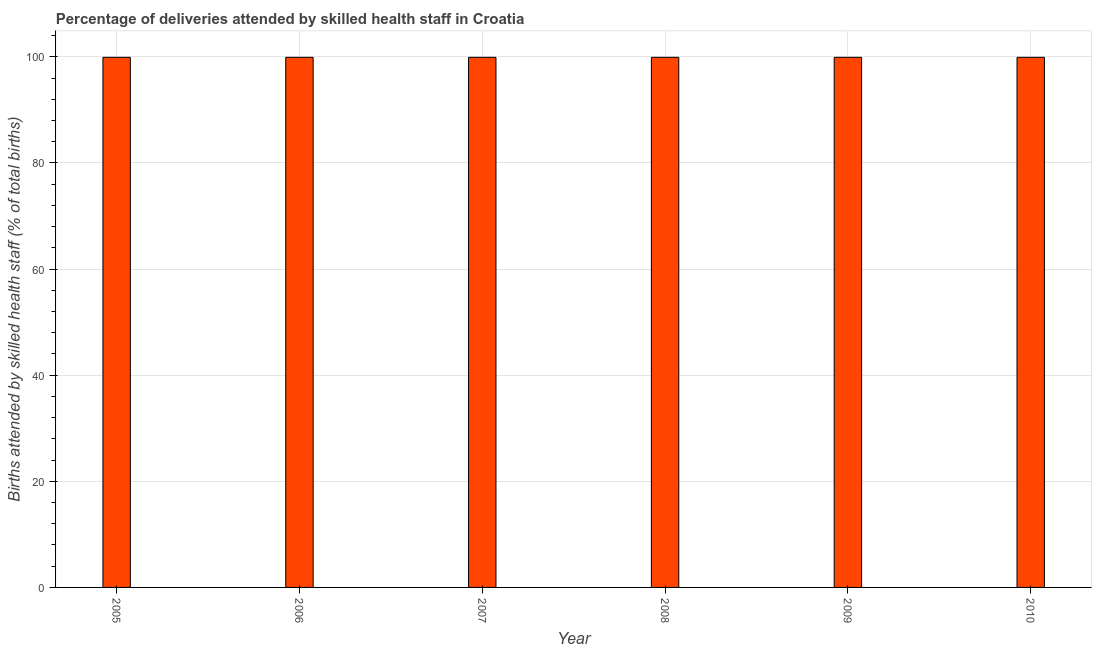What is the title of the graph?
Your answer should be compact. Percentage of deliveries attended by skilled health staff in Croatia. What is the label or title of the Y-axis?
Your response must be concise. Births attended by skilled health staff (% of total births). What is the number of births attended by skilled health staff in 2009?
Keep it short and to the point. 99.9. Across all years, what is the maximum number of births attended by skilled health staff?
Your answer should be very brief. 99.9. Across all years, what is the minimum number of births attended by skilled health staff?
Make the answer very short. 99.9. In which year was the number of births attended by skilled health staff minimum?
Your answer should be compact. 2005. What is the sum of the number of births attended by skilled health staff?
Provide a succinct answer. 599.4. What is the average number of births attended by skilled health staff per year?
Make the answer very short. 99.9. What is the median number of births attended by skilled health staff?
Give a very brief answer. 99.9. Do a majority of the years between 2008 and 2006 (inclusive) have number of births attended by skilled health staff greater than 40 %?
Provide a short and direct response. Yes. Is the number of births attended by skilled health staff in 2007 less than that in 2008?
Your answer should be very brief. No. Is the difference between the number of births attended by skilled health staff in 2005 and 2010 greater than the difference between any two years?
Your response must be concise. Yes. Is the sum of the number of births attended by skilled health staff in 2006 and 2007 greater than the maximum number of births attended by skilled health staff across all years?
Provide a short and direct response. Yes. What is the difference between the highest and the lowest number of births attended by skilled health staff?
Offer a very short reply. 0. In how many years, is the number of births attended by skilled health staff greater than the average number of births attended by skilled health staff taken over all years?
Provide a succinct answer. 6. How many bars are there?
Your answer should be very brief. 6. Are all the bars in the graph horizontal?
Keep it short and to the point. No. How many years are there in the graph?
Make the answer very short. 6. What is the difference between two consecutive major ticks on the Y-axis?
Your response must be concise. 20. Are the values on the major ticks of Y-axis written in scientific E-notation?
Your response must be concise. No. What is the Births attended by skilled health staff (% of total births) in 2005?
Your answer should be compact. 99.9. What is the Births attended by skilled health staff (% of total births) of 2006?
Provide a succinct answer. 99.9. What is the Births attended by skilled health staff (% of total births) of 2007?
Your answer should be very brief. 99.9. What is the Births attended by skilled health staff (% of total births) of 2008?
Offer a terse response. 99.9. What is the Births attended by skilled health staff (% of total births) of 2009?
Offer a very short reply. 99.9. What is the Births attended by skilled health staff (% of total births) of 2010?
Provide a succinct answer. 99.9. What is the difference between the Births attended by skilled health staff (% of total births) in 2005 and 2008?
Your answer should be compact. 0. What is the difference between the Births attended by skilled health staff (% of total births) in 2005 and 2010?
Keep it short and to the point. 0. What is the difference between the Births attended by skilled health staff (% of total births) in 2006 and 2008?
Give a very brief answer. 0. What is the difference between the Births attended by skilled health staff (% of total births) in 2006 and 2010?
Your answer should be very brief. 0. What is the difference between the Births attended by skilled health staff (% of total births) in 2008 and 2009?
Offer a very short reply. 0. What is the difference between the Births attended by skilled health staff (% of total births) in 2009 and 2010?
Ensure brevity in your answer.  0. What is the ratio of the Births attended by skilled health staff (% of total births) in 2005 to that in 2007?
Keep it short and to the point. 1. What is the ratio of the Births attended by skilled health staff (% of total births) in 2005 to that in 2008?
Your answer should be very brief. 1. What is the ratio of the Births attended by skilled health staff (% of total births) in 2005 to that in 2009?
Give a very brief answer. 1. What is the ratio of the Births attended by skilled health staff (% of total births) in 2006 to that in 2007?
Offer a very short reply. 1. What is the ratio of the Births attended by skilled health staff (% of total births) in 2006 to that in 2009?
Offer a very short reply. 1. What is the ratio of the Births attended by skilled health staff (% of total births) in 2006 to that in 2010?
Ensure brevity in your answer.  1. What is the ratio of the Births attended by skilled health staff (% of total births) in 2007 to that in 2008?
Provide a short and direct response. 1. What is the ratio of the Births attended by skilled health staff (% of total births) in 2007 to that in 2009?
Give a very brief answer. 1. What is the ratio of the Births attended by skilled health staff (% of total births) in 2008 to that in 2009?
Your response must be concise. 1. What is the ratio of the Births attended by skilled health staff (% of total births) in 2009 to that in 2010?
Provide a short and direct response. 1. 